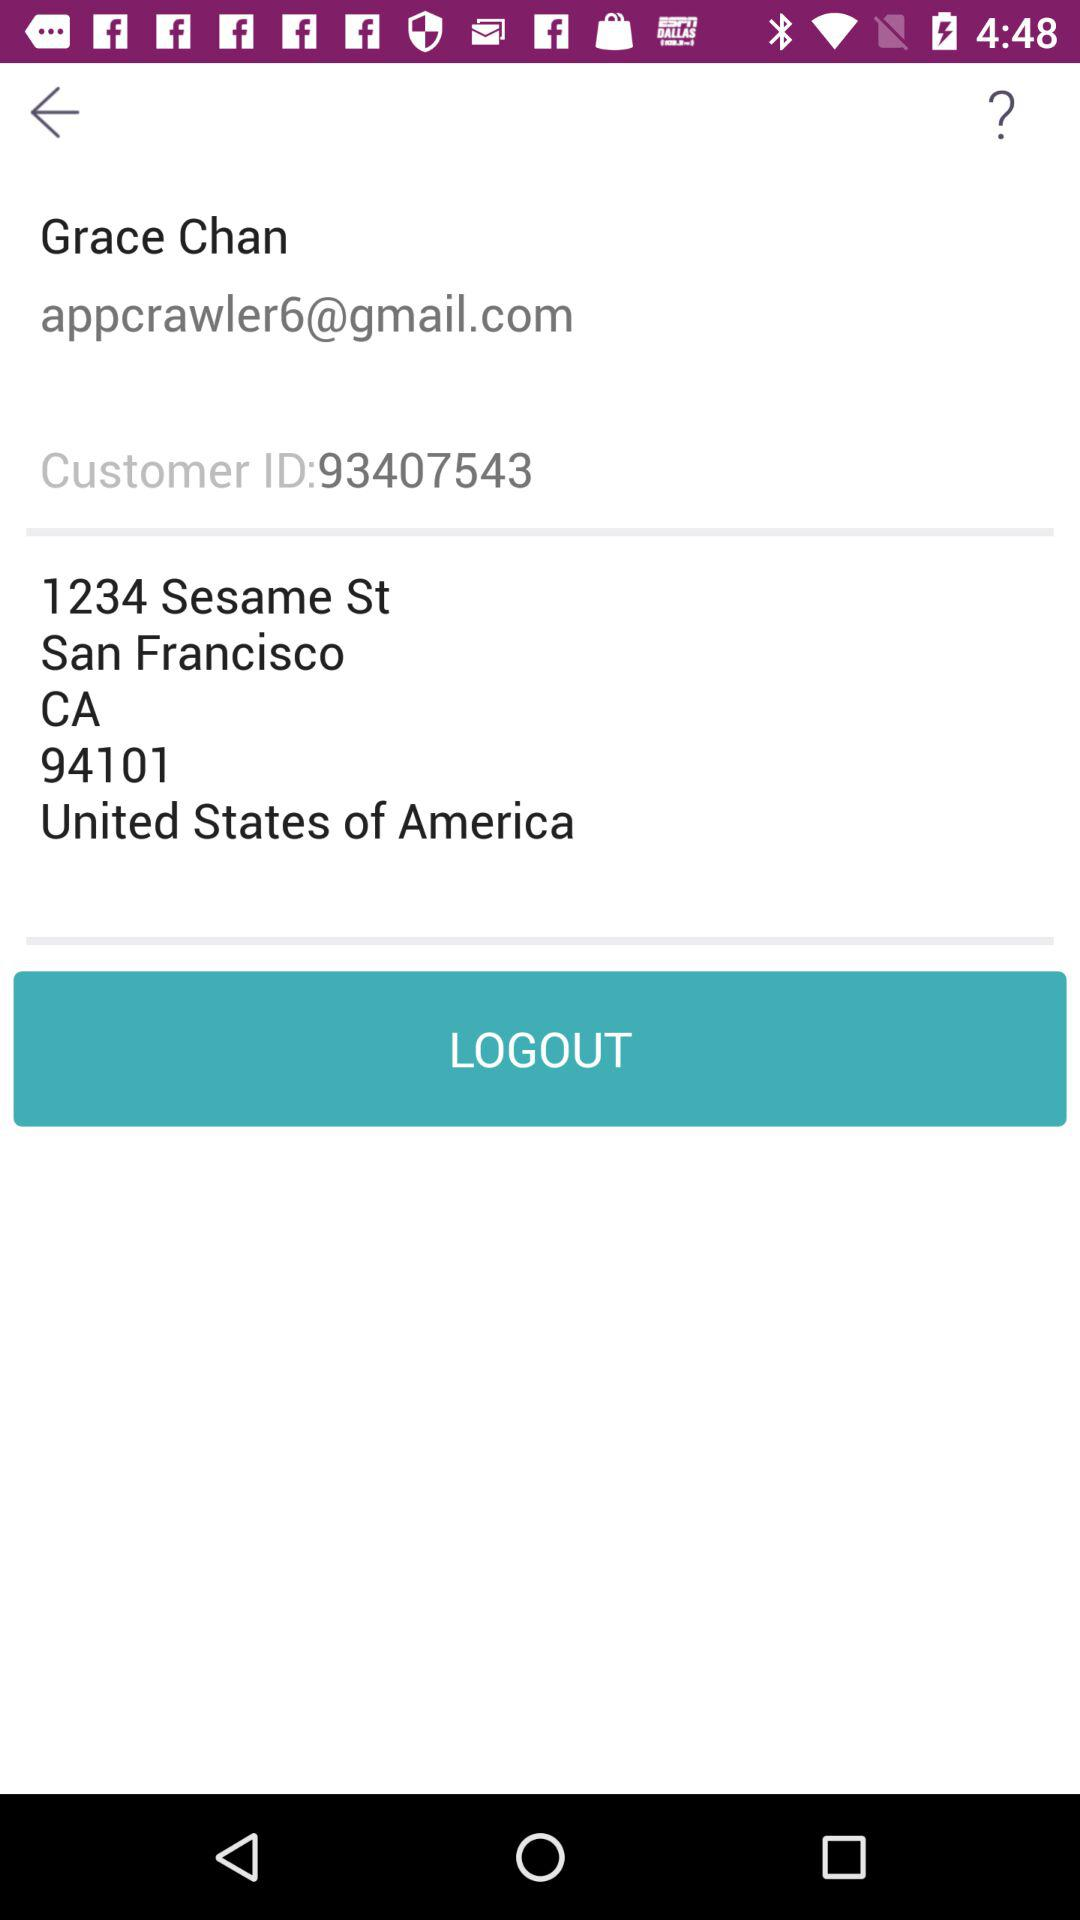What is the email address of the user? The email address of the user is appcrawler6@gmail.com. 